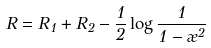<formula> <loc_0><loc_0><loc_500><loc_500>R = R _ { 1 } + R _ { 2 } - \frac { 1 } { 2 } \log \frac { 1 } { 1 - \rho ^ { 2 } }</formula> 